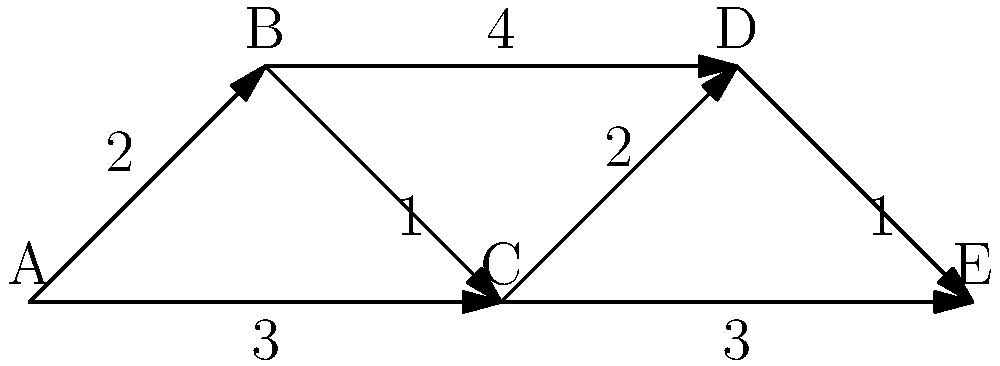In the graph representing EU member states, where each node is a country and edges represent direct connections with associated travel times (in hours), what is the shortest travel time from country A to country E? How might this information be relevant to reporting on EU affairs and potential inefficiencies in cross-border travel? To find the shortest path from country A to country E, we need to consider all possible routes and their total travel times. Let's break it down step-by-step:

1. Possible routes from A to E:
   a) A → B → C → E
   b) A → B → D → E
   c) A → C → E
   d) A → C → D → E

2. Calculate the travel time for each route:
   a) A → B → C → E: 2 + 1 + 3 = 6 hours
   b) A → B → D → E: 2 + 4 + 1 = 7 hours
   c) A → C → E: 3 + 3 = 6 hours
   d) A → C → D → E: 3 + 2 + 1 = 6 hours

3. Identify the shortest path:
   Routes (a), (c), and (d) all have the same travel time of 6 hours, which is the shortest.

4. Relevance to reporting on EU affairs:
   - This information could be used to highlight inefficiencies in cross-border travel within the EU.
   - It may raise questions about the need for improved transportation infrastructure between member states.
   - The data could support arguments for or against closer integration of EU countries.
   - It could be used to analyze the impact of travel times on trade, tourism, and cultural exchange between EU nations.
   - The information might reveal disparities in connectivity between different regions of the EU.

As a Euro-sceptic journalist, this data could be used to critique the EU's effectiveness in creating a truly integrated and efficient travel network among member states, potentially highlighting areas where national sovereignty in transportation planning might be more beneficial.
Answer: 6 hours 